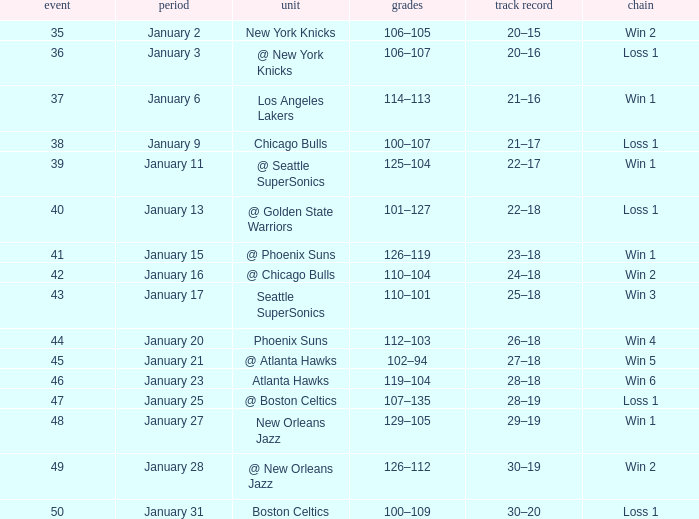What is the Streak in the game with a Record of 20–16? Loss 1. Give me the full table as a dictionary. {'header': ['event', 'period', 'unit', 'grades', 'track record', 'chain'], 'rows': [['35', 'January 2', 'New York Knicks', '106–105', '20–15', 'Win 2'], ['36', 'January 3', '@ New York Knicks', '106–107', '20–16', 'Loss 1'], ['37', 'January 6', 'Los Angeles Lakers', '114–113', '21–16', 'Win 1'], ['38', 'January 9', 'Chicago Bulls', '100–107', '21–17', 'Loss 1'], ['39', 'January 11', '@ Seattle SuperSonics', '125–104', '22–17', 'Win 1'], ['40', 'January 13', '@ Golden State Warriors', '101–127', '22–18', 'Loss 1'], ['41', 'January 15', '@ Phoenix Suns', '126–119', '23–18', 'Win 1'], ['42', 'January 16', '@ Chicago Bulls', '110–104', '24–18', 'Win 2'], ['43', 'January 17', 'Seattle SuperSonics', '110–101', '25–18', 'Win 3'], ['44', 'January 20', 'Phoenix Suns', '112–103', '26–18', 'Win 4'], ['45', 'January 21', '@ Atlanta Hawks', '102–94', '27–18', 'Win 5'], ['46', 'January 23', 'Atlanta Hawks', '119–104', '28–18', 'Win 6'], ['47', 'January 25', '@ Boston Celtics', '107–135', '28–19', 'Loss 1'], ['48', 'January 27', 'New Orleans Jazz', '129–105', '29–19', 'Win 1'], ['49', 'January 28', '@ New Orleans Jazz', '126–112', '30–19', 'Win 2'], ['50', 'January 31', 'Boston Celtics', '100–109', '30–20', 'Loss 1']]} 